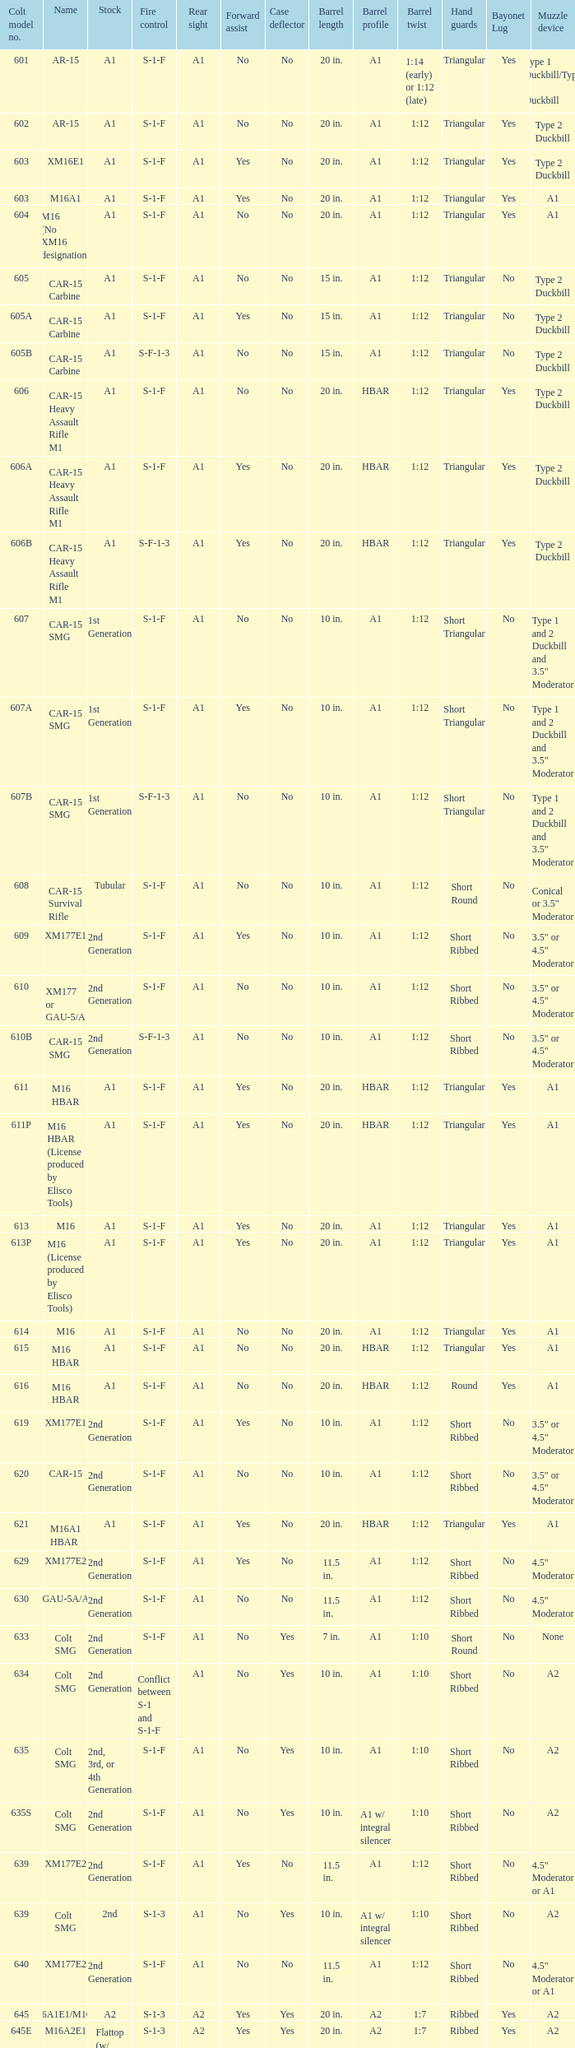In the cole model no. 735, what does the rear sight consist of? A1 or A2. 